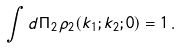<formula> <loc_0><loc_0><loc_500><loc_500>\int d \Pi _ { 2 } \, \rho _ { 2 } ( k _ { 1 } ; k _ { 2 } ; 0 ) = 1 \, .</formula> 